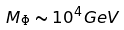Convert formula to latex. <formula><loc_0><loc_0><loc_500><loc_500>M _ { \Phi } \sim 1 0 ^ { 4 } G e V</formula> 